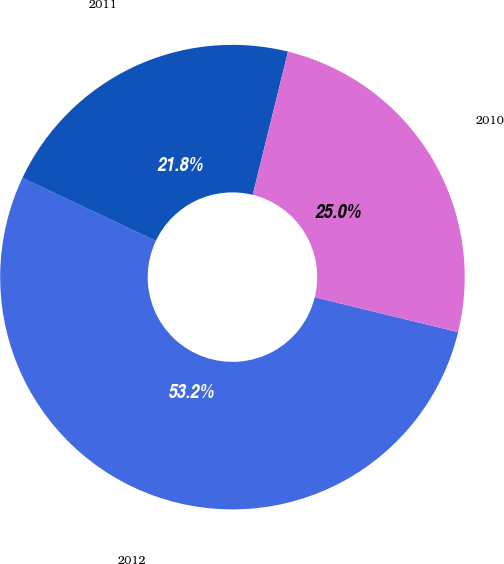<chart> <loc_0><loc_0><loc_500><loc_500><pie_chart><fcel>2012<fcel>2011<fcel>2010<nl><fcel>53.22%<fcel>21.82%<fcel>24.96%<nl></chart> 